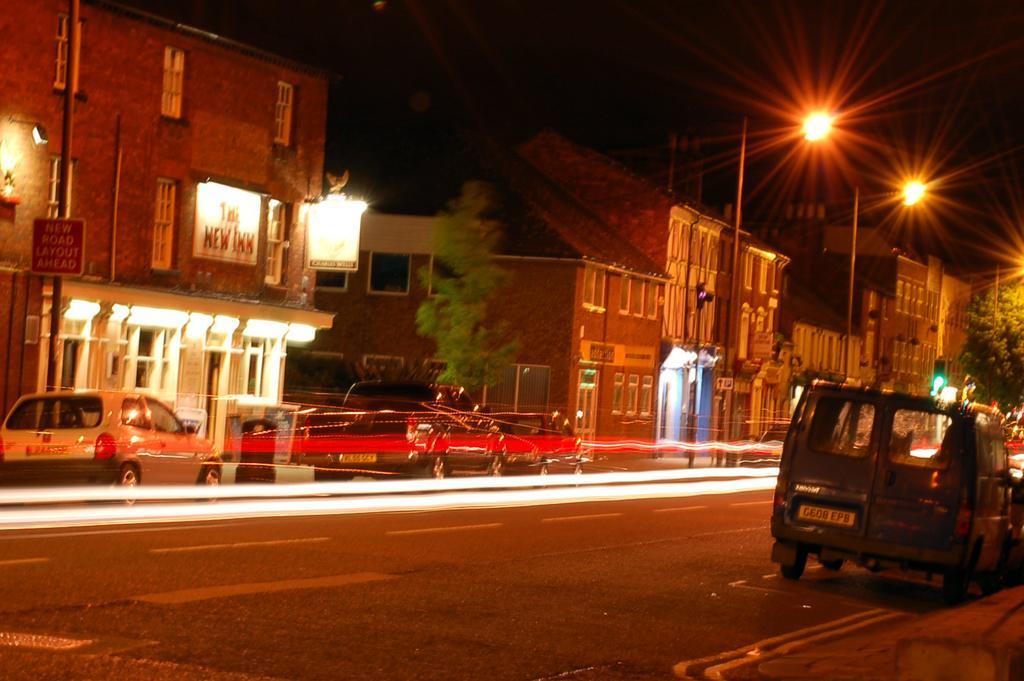Could you give a brief overview of what you see in this image? In this image I can see there are few vehicles visible on the road I can see street light pole , buildings and plants visible ,at the top I can see the sky and this picture is taken during night. 